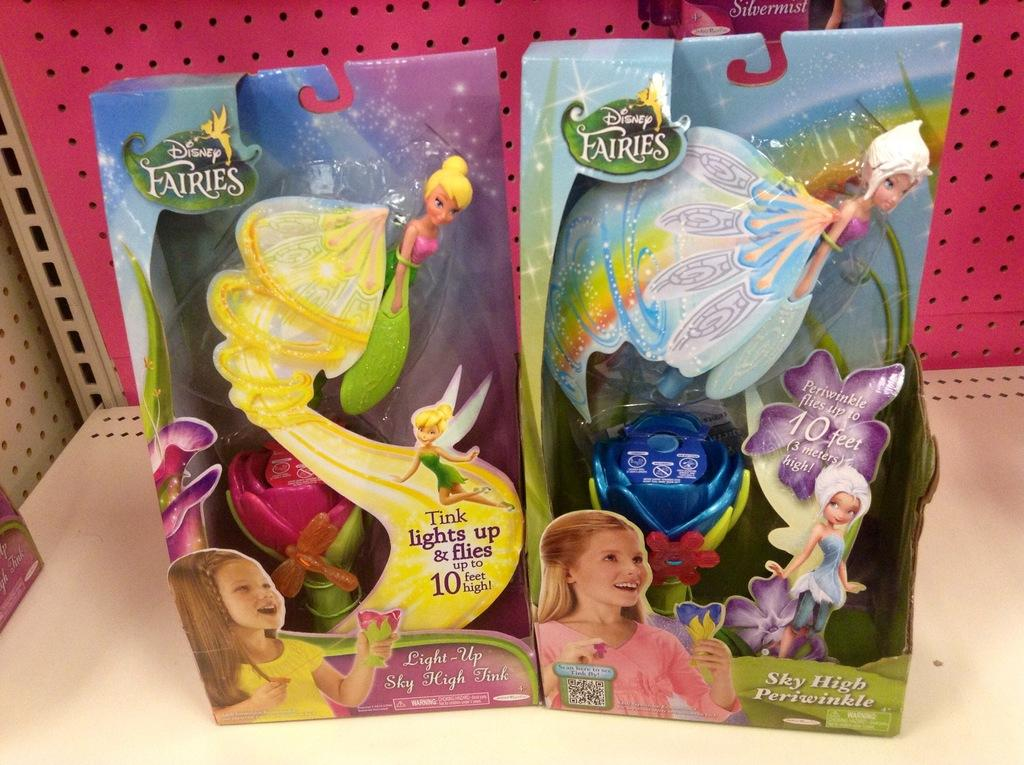What objects are present in the image? There are boxes in the image. Where are the boxes located? The boxes are on a rack. What type of pipe can be seen in the image? There is no pipe present in the image; it only features boxes on a rack. 